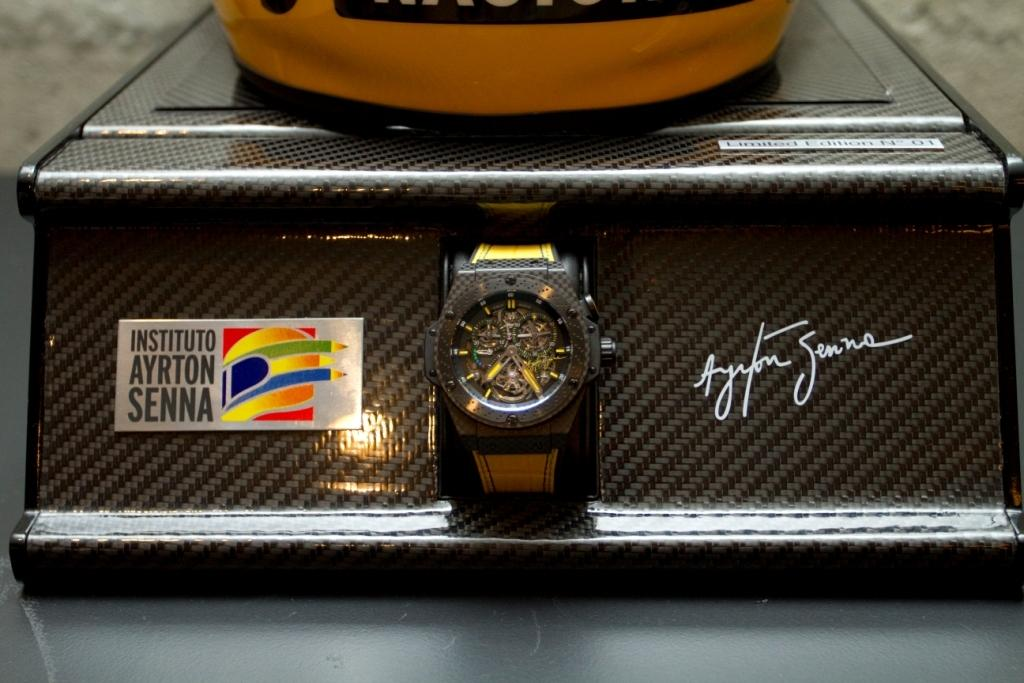What object can be seen in the image? There is a watch in the image. What additional element is present in the image? There is a logo in the image. Is there any text or marking in the image? Yes, there is a signature in the image. Can you see any mountains in the image? There are no mountains present in the image. What sense is being stimulated by the watch in the image? The watch is a visual object, so it primarily stimulates the sense of sight. However, it may also be associated with the sense of touch when worn on the wrist. 